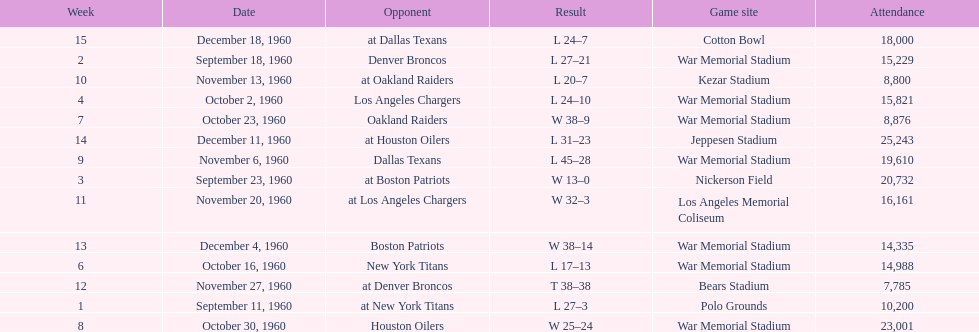How many games had an attendance of 10,000 at most? 11. 